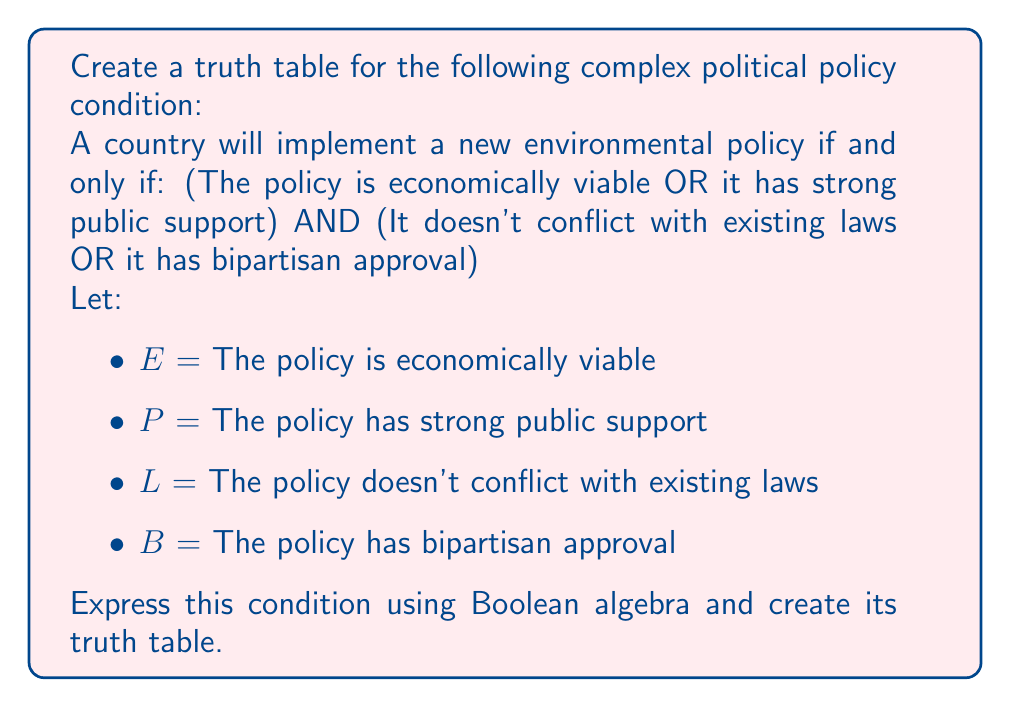Provide a solution to this math problem. Step 1: Express the condition using Boolean algebra
The given condition can be expressed as:
$$(E \lor P) \land (L \lor B)$$

Step 2: Identify the number of variables
There are 4 variables (E, P, L, B), so our truth table will have $2^4 = 16$ rows.

Step 3: Create the truth table
Let's create the table step by step:

1. List all possible combinations of E, P, L, and B
2. Evaluate $(E \lor P)$
3. Evaluate $(L \lor B)$
4. Evaluate the final result $(E \lor P) \land (L \lor B)$

$$\begin{array}{|c|c|c|c|c|c|c|}
\hline
E & P & L & B & (E \lor P) & (L \lor B) & (E \lor P) \land (L \lor B) \\
\hline
0 & 0 & 0 & 0 & 0 & 0 & 0 \\
0 & 0 & 0 & 1 & 0 & 1 & 0 \\
0 & 0 & 1 & 0 & 0 & 1 & 0 \\
0 & 0 & 1 & 1 & 0 & 1 & 0 \\
0 & 1 & 0 & 0 & 1 & 0 & 0 \\
0 & 1 & 0 & 1 & 1 & 1 & 1 \\
0 & 1 & 1 & 0 & 1 & 1 & 1 \\
0 & 1 & 1 & 1 & 1 & 1 & 1 \\
1 & 0 & 0 & 0 & 1 & 0 & 0 \\
1 & 0 & 0 & 1 & 1 & 1 & 1 \\
1 & 0 & 1 & 0 & 1 & 1 & 1 \\
1 & 0 & 1 & 1 & 1 & 1 & 1 \\
1 & 1 & 0 & 0 & 1 & 0 & 0 \\
1 & 1 & 0 & 1 & 1 & 1 & 1 \\
1 & 1 & 1 & 0 & 1 & 1 & 1 \\
1 & 1 & 1 & 1 & 1 & 1 & 1 \\
\hline
\end{array}$$

The truth table shows all possible combinations of the variables and the resulting output of the Boolean expression.
Answer: $$(E \lor P) \land (L \lor B)$$ 